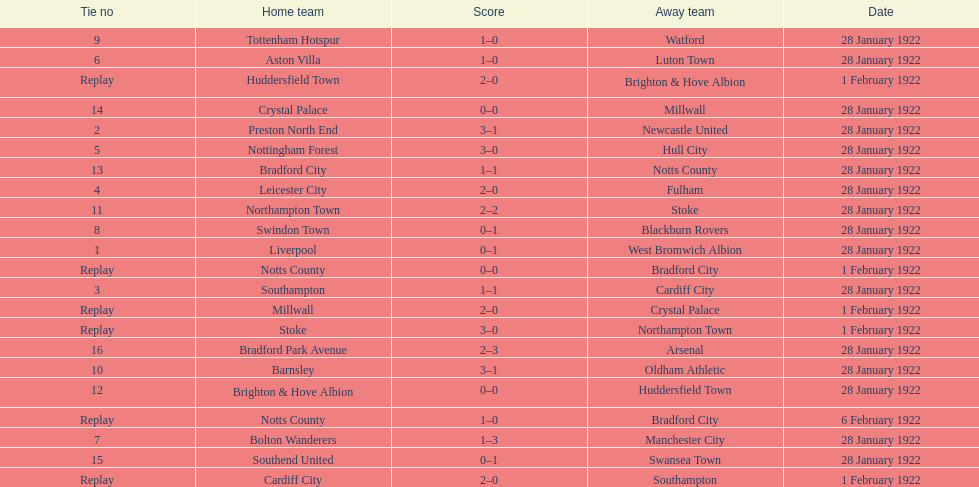What home team had the same score as aston villa on january 28th, 1922? Tottenham Hotspur. 